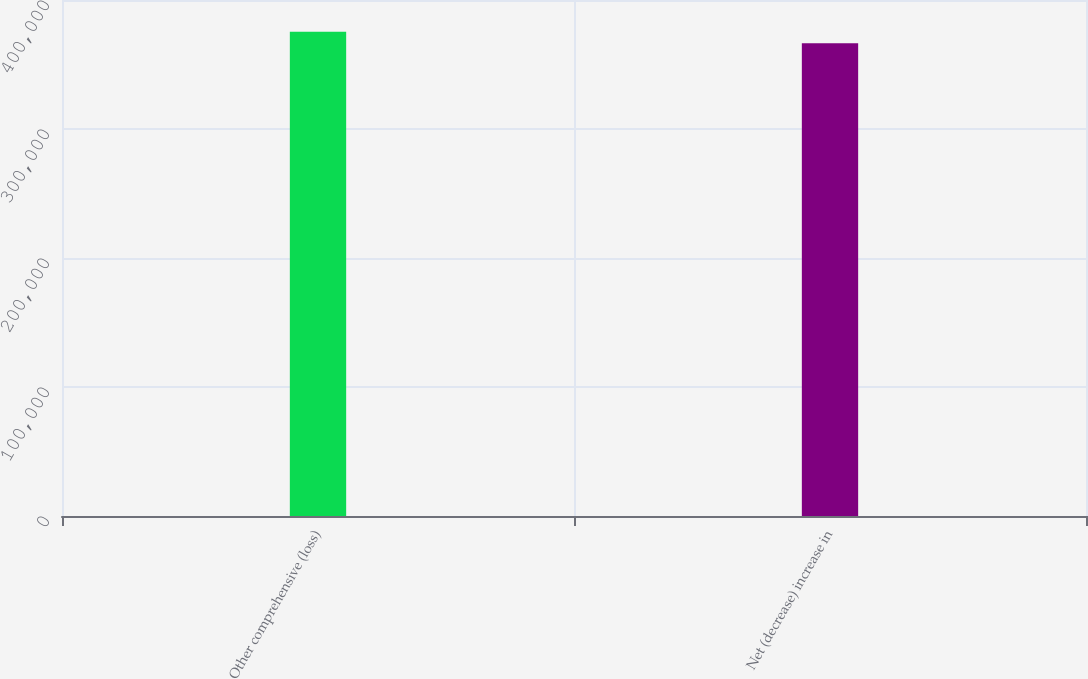<chart> <loc_0><loc_0><loc_500><loc_500><bar_chart><fcel>Other comprehensive (loss)<fcel>Net (decrease) increase in<nl><fcel>375311<fcel>366544<nl></chart> 